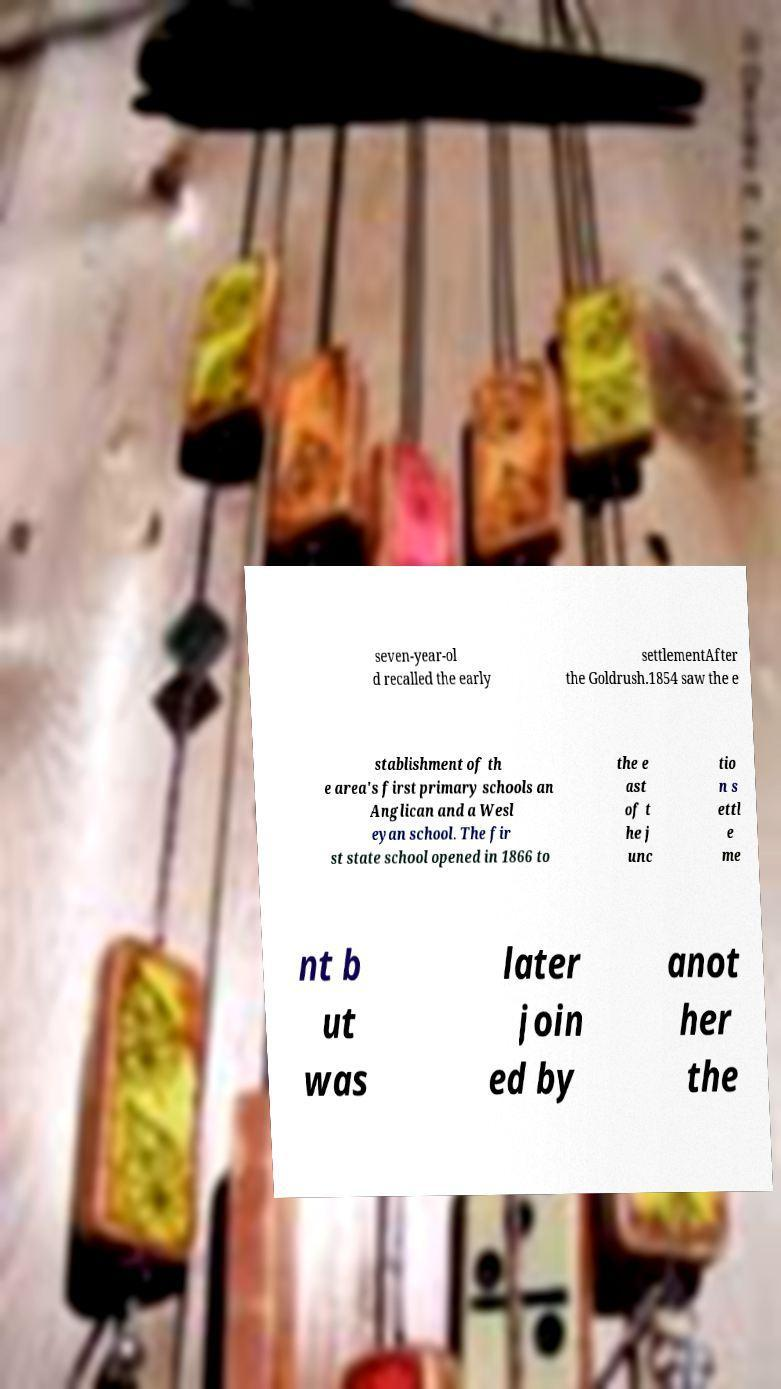Could you assist in decoding the text presented in this image and type it out clearly? seven-year-ol d recalled the early settlementAfter the Goldrush.1854 saw the e stablishment of th e area's first primary schools an Anglican and a Wesl eyan school. The fir st state school opened in 1866 to the e ast of t he j unc tio n s ettl e me nt b ut was later join ed by anot her the 